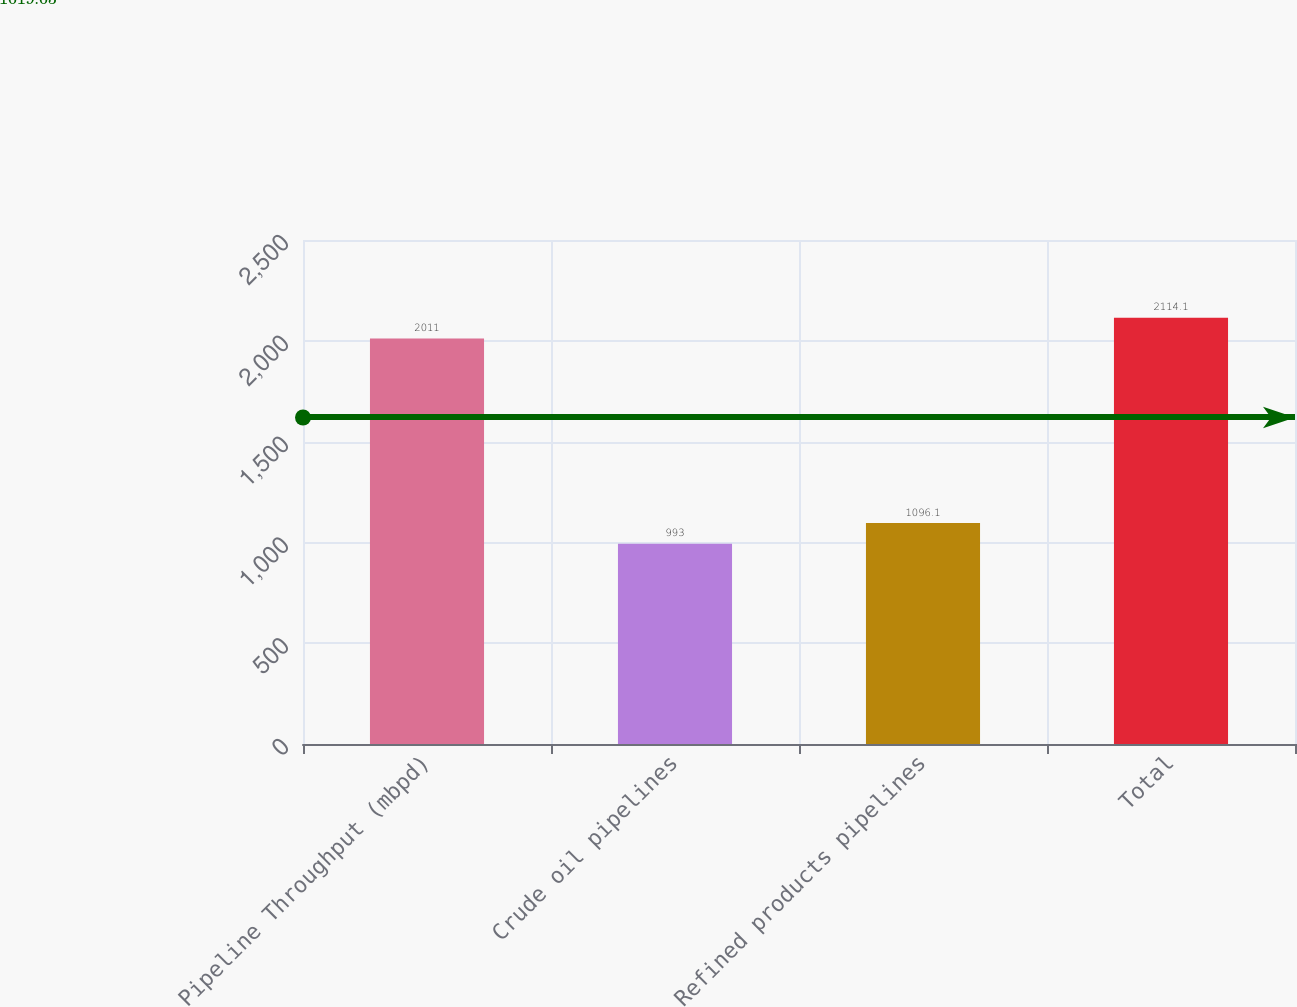Convert chart to OTSL. <chart><loc_0><loc_0><loc_500><loc_500><bar_chart><fcel>Pipeline Throughput (mbpd)<fcel>Crude oil pipelines<fcel>Refined products pipelines<fcel>Total<nl><fcel>2011<fcel>993<fcel>1096.1<fcel>2114.1<nl></chart> 